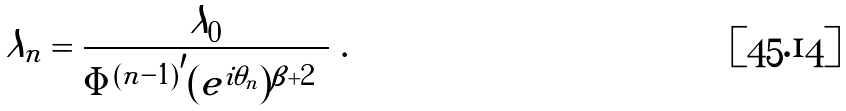<formula> <loc_0><loc_0><loc_500><loc_500>\lambda _ { n } = \frac { \lambda _ { 0 } } { | { \Phi ^ { ( n - 1 ) } } ^ { \prime } ( e ^ { i \theta _ { n } } ) | ^ { \beta + 2 } } \ .</formula> 